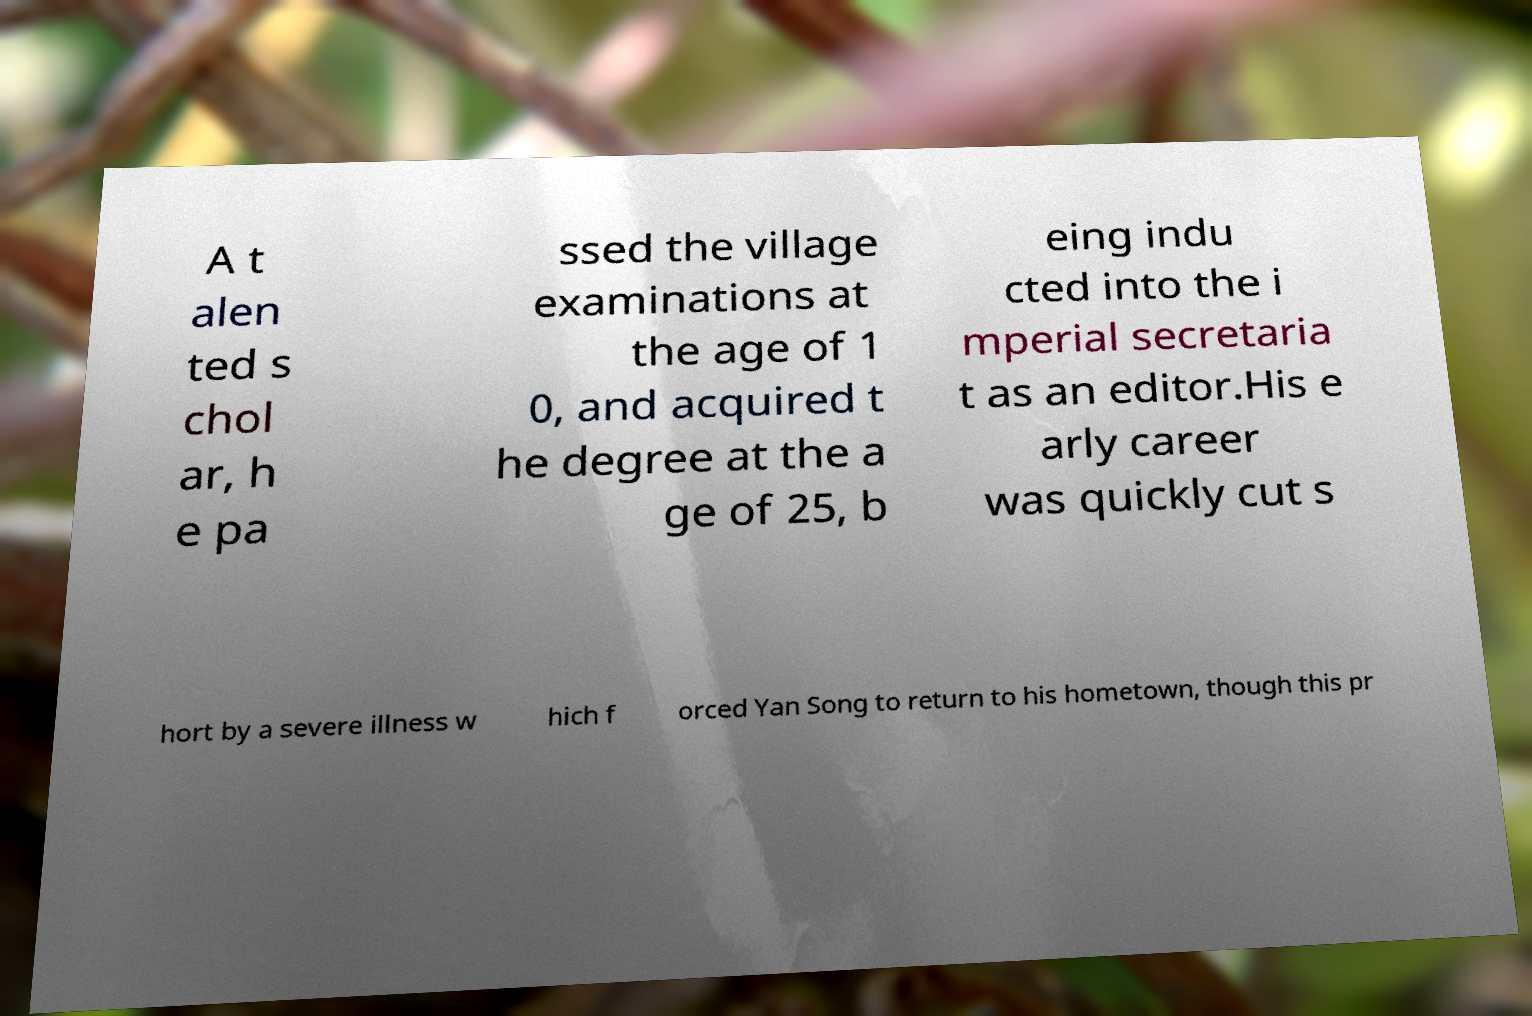Could you assist in decoding the text presented in this image and type it out clearly? A t alen ted s chol ar, h e pa ssed the village examinations at the age of 1 0, and acquired t he degree at the a ge of 25, b eing indu cted into the i mperial secretaria t as an editor.His e arly career was quickly cut s hort by a severe illness w hich f orced Yan Song to return to his hometown, though this pr 